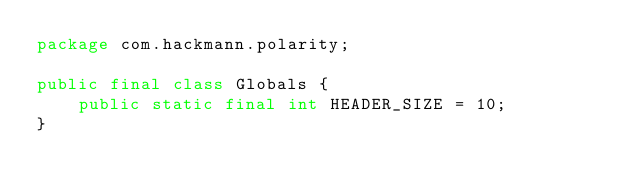Convert code to text. <code><loc_0><loc_0><loc_500><loc_500><_Java_>package com.hackmann.polarity;

public final class Globals {
    public static final int HEADER_SIZE = 10;
}
</code> 